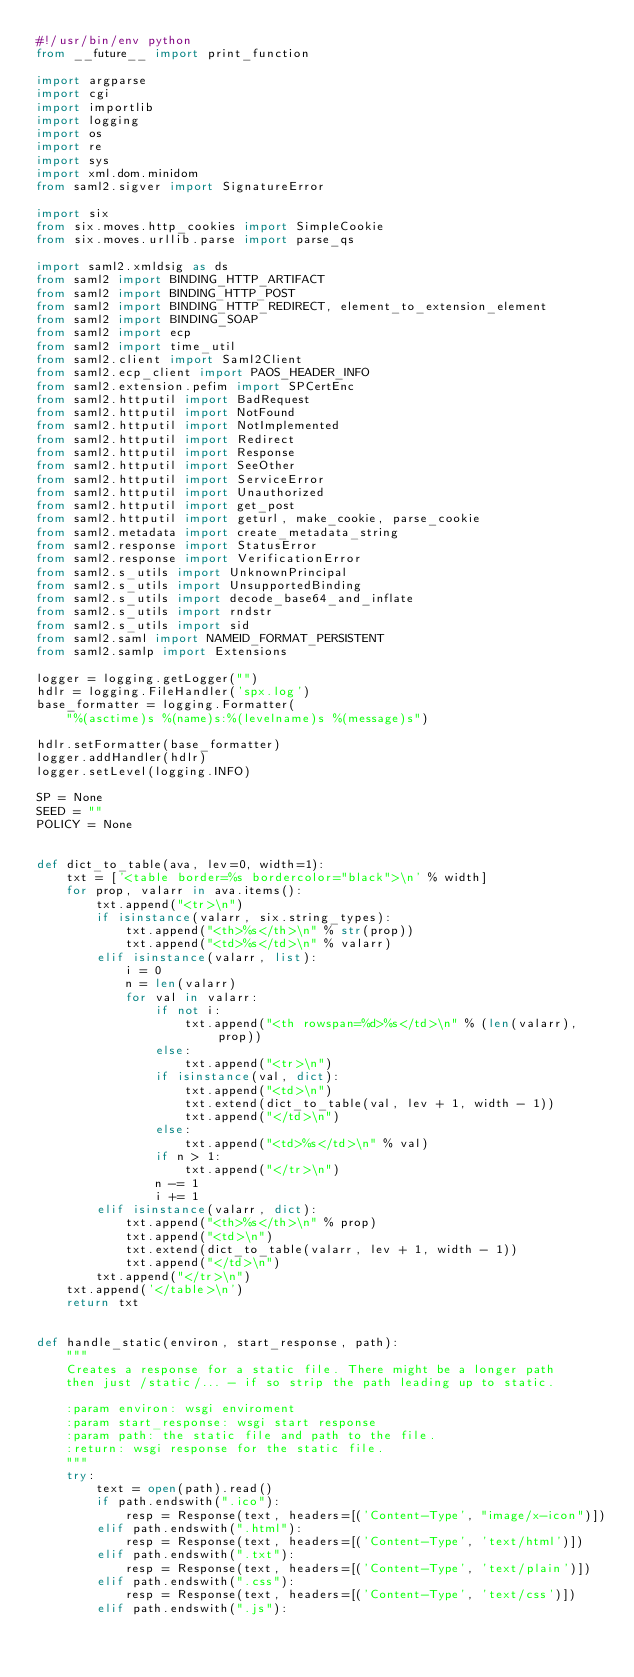<code> <loc_0><loc_0><loc_500><loc_500><_Python_>#!/usr/bin/env python
from __future__ import print_function

import argparse
import cgi
import importlib
import logging
import os
import re
import sys
import xml.dom.minidom
from saml2.sigver import SignatureError

import six
from six.moves.http_cookies import SimpleCookie
from six.moves.urllib.parse import parse_qs

import saml2.xmldsig as ds
from saml2 import BINDING_HTTP_ARTIFACT
from saml2 import BINDING_HTTP_POST
from saml2 import BINDING_HTTP_REDIRECT, element_to_extension_element
from saml2 import BINDING_SOAP
from saml2 import ecp
from saml2 import time_util
from saml2.client import Saml2Client
from saml2.ecp_client import PAOS_HEADER_INFO
from saml2.extension.pefim import SPCertEnc
from saml2.httputil import BadRequest
from saml2.httputil import NotFound
from saml2.httputil import NotImplemented
from saml2.httputil import Redirect
from saml2.httputil import Response
from saml2.httputil import SeeOther
from saml2.httputil import ServiceError
from saml2.httputil import Unauthorized
from saml2.httputil import get_post
from saml2.httputil import geturl, make_cookie, parse_cookie
from saml2.metadata import create_metadata_string
from saml2.response import StatusError
from saml2.response import VerificationError
from saml2.s_utils import UnknownPrincipal
from saml2.s_utils import UnsupportedBinding
from saml2.s_utils import decode_base64_and_inflate
from saml2.s_utils import rndstr
from saml2.s_utils import sid
from saml2.saml import NAMEID_FORMAT_PERSISTENT
from saml2.samlp import Extensions

logger = logging.getLogger("")
hdlr = logging.FileHandler('spx.log')
base_formatter = logging.Formatter(
    "%(asctime)s %(name)s:%(levelname)s %(message)s")

hdlr.setFormatter(base_formatter)
logger.addHandler(hdlr)
logger.setLevel(logging.INFO)

SP = None
SEED = ""
POLICY = None


def dict_to_table(ava, lev=0, width=1):
    txt = ['<table border=%s bordercolor="black">\n' % width]
    for prop, valarr in ava.items():
        txt.append("<tr>\n")
        if isinstance(valarr, six.string_types):
            txt.append("<th>%s</th>\n" % str(prop))
            txt.append("<td>%s</td>\n" % valarr)
        elif isinstance(valarr, list):
            i = 0
            n = len(valarr)
            for val in valarr:
                if not i:
                    txt.append("<th rowspan=%d>%s</td>\n" % (len(valarr), prop))
                else:
                    txt.append("<tr>\n")
                if isinstance(val, dict):
                    txt.append("<td>\n")
                    txt.extend(dict_to_table(val, lev + 1, width - 1))
                    txt.append("</td>\n")
                else:
                    txt.append("<td>%s</td>\n" % val)
                if n > 1:
                    txt.append("</tr>\n")
                n -= 1
                i += 1
        elif isinstance(valarr, dict):
            txt.append("<th>%s</th>\n" % prop)
            txt.append("<td>\n")
            txt.extend(dict_to_table(valarr, lev + 1, width - 1))
            txt.append("</td>\n")
        txt.append("</tr>\n")
    txt.append('</table>\n')
    return txt


def handle_static(environ, start_response, path):
    """
    Creates a response for a static file. There might be a longer path
    then just /static/... - if so strip the path leading up to static.

    :param environ: wsgi enviroment
    :param start_response: wsgi start response
    :param path: the static file and path to the file.
    :return: wsgi response for the static file.
    """
    try:
        text = open(path).read()
        if path.endswith(".ico"):
            resp = Response(text, headers=[('Content-Type', "image/x-icon")])
        elif path.endswith(".html"):
            resp = Response(text, headers=[('Content-Type', 'text/html')])
        elif path.endswith(".txt"):
            resp = Response(text, headers=[('Content-Type', 'text/plain')])
        elif path.endswith(".css"):
            resp = Response(text, headers=[('Content-Type', 'text/css')])
        elif path.endswith(".js"):</code> 